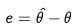Convert formula to latex. <formula><loc_0><loc_0><loc_500><loc_500>e = \hat { \theta } - \theta</formula> 